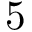<formula> <loc_0><loc_0><loc_500><loc_500>5</formula> 